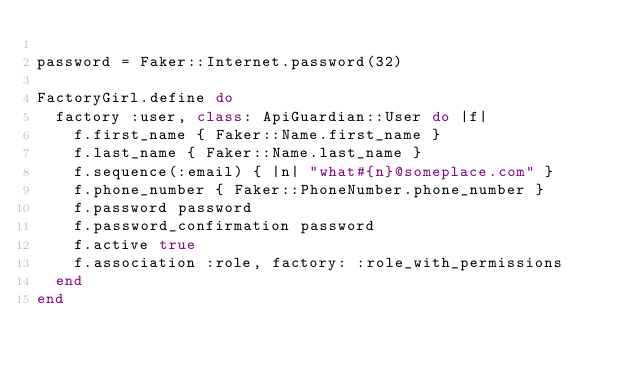Convert code to text. <code><loc_0><loc_0><loc_500><loc_500><_Ruby_>
password = Faker::Internet.password(32)

FactoryGirl.define do
  factory :user, class: ApiGuardian::User do |f|
    f.first_name { Faker::Name.first_name }
    f.last_name { Faker::Name.last_name }
    f.sequence(:email) { |n| "what#{n}@someplace.com" }
    f.phone_number { Faker::PhoneNumber.phone_number }
    f.password password
    f.password_confirmation password
    f.active true
    f.association :role, factory: :role_with_permissions
  end
end
</code> 